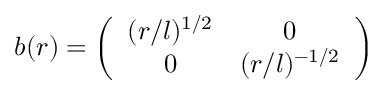Convert formula to latex. <formula><loc_0><loc_0><loc_500><loc_500>b ( r ) = \left ( \begin{array} { c c } { { ( r / l ) ^ { 1 / 2 } } } & { 0 } \\ { 0 } & { { ( r / l ) ^ { - 1 / 2 } } } \end{array} \right )</formula> 